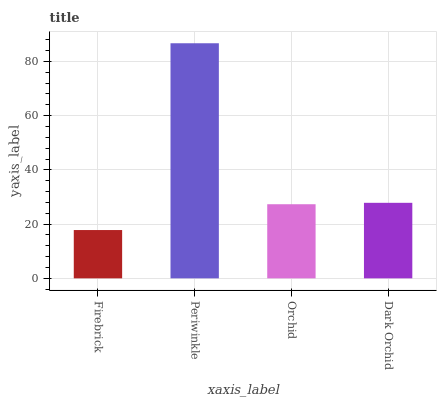Is Firebrick the minimum?
Answer yes or no. Yes. Is Periwinkle the maximum?
Answer yes or no. Yes. Is Orchid the minimum?
Answer yes or no. No. Is Orchid the maximum?
Answer yes or no. No. Is Periwinkle greater than Orchid?
Answer yes or no. Yes. Is Orchid less than Periwinkle?
Answer yes or no. Yes. Is Orchid greater than Periwinkle?
Answer yes or no. No. Is Periwinkle less than Orchid?
Answer yes or no. No. Is Dark Orchid the high median?
Answer yes or no. Yes. Is Orchid the low median?
Answer yes or no. Yes. Is Periwinkle the high median?
Answer yes or no. No. Is Dark Orchid the low median?
Answer yes or no. No. 